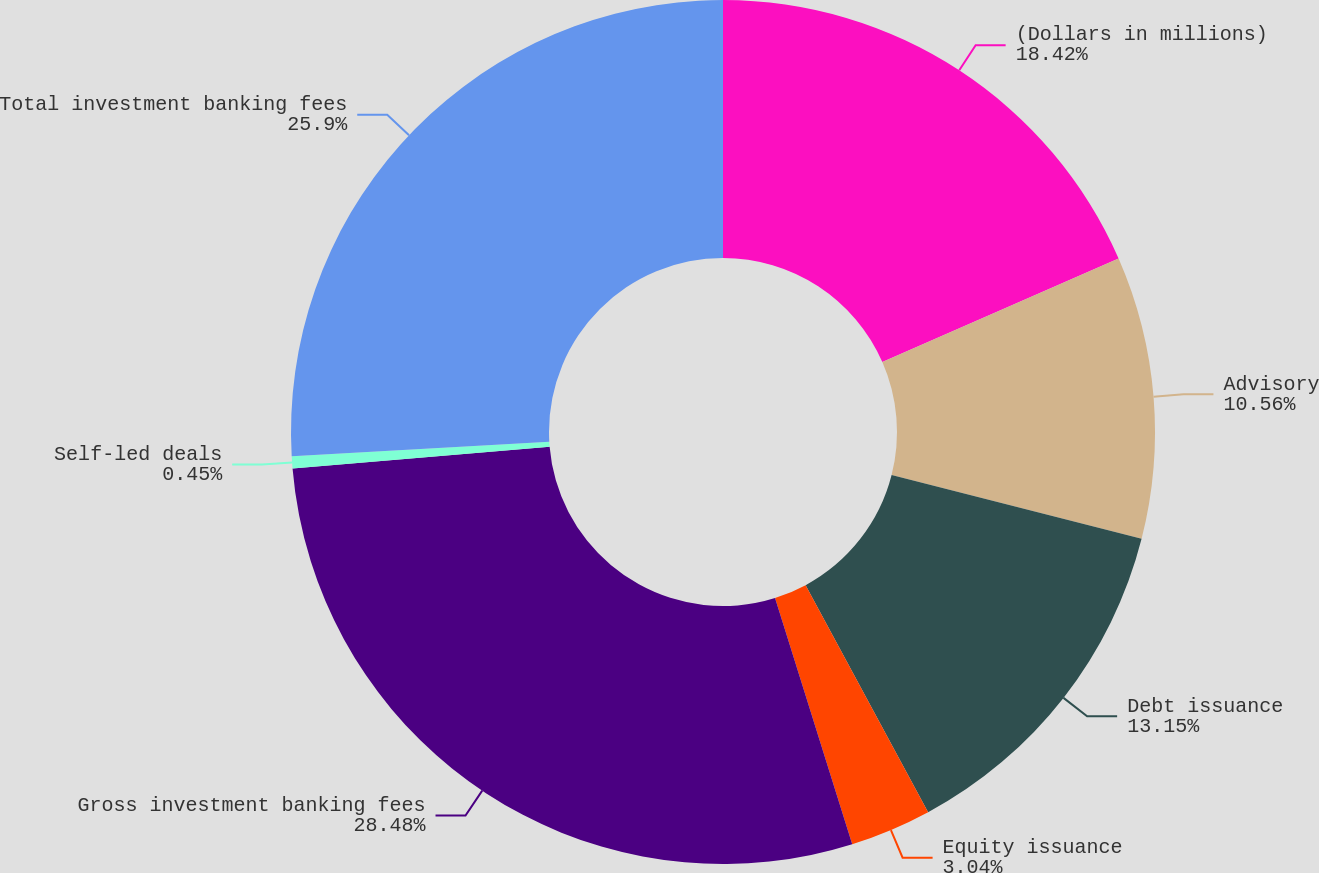<chart> <loc_0><loc_0><loc_500><loc_500><pie_chart><fcel>(Dollars in millions)<fcel>Advisory<fcel>Debt issuance<fcel>Equity issuance<fcel>Gross investment banking fees<fcel>Self-led deals<fcel>Total investment banking fees<nl><fcel>18.42%<fcel>10.56%<fcel>13.15%<fcel>3.04%<fcel>28.49%<fcel>0.45%<fcel>25.9%<nl></chart> 